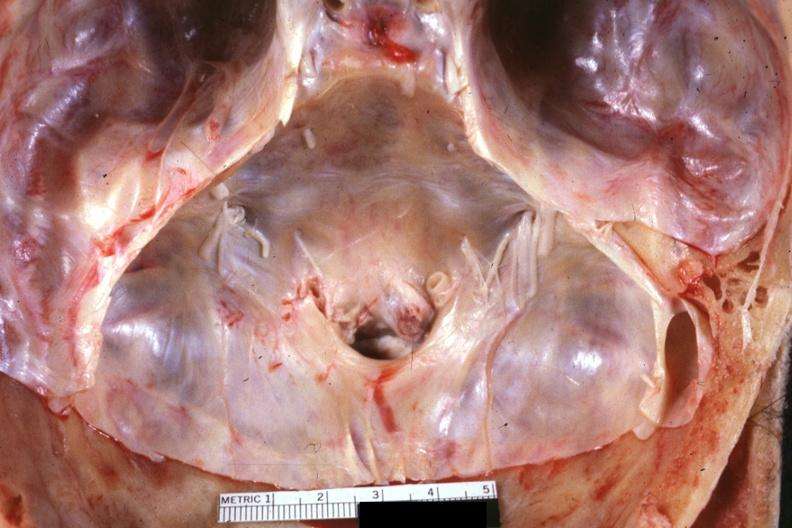what is present?
Answer the question using a single word or phrase. Rheumatoid arthritis 